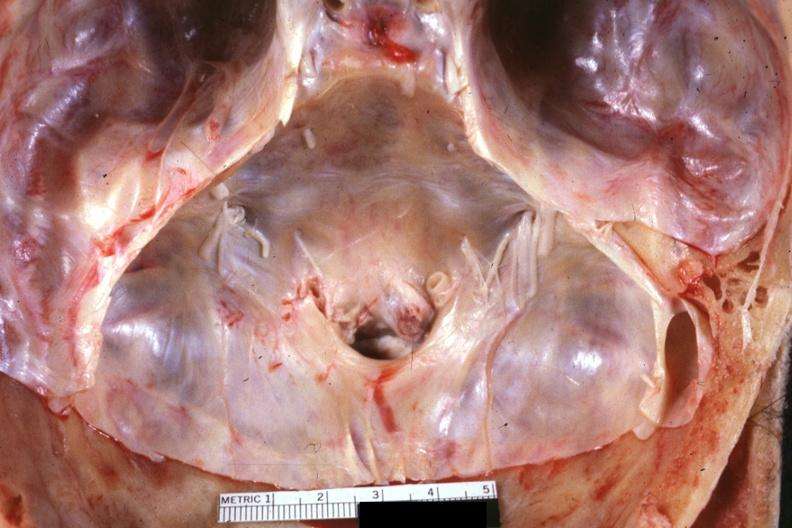what is present?
Answer the question using a single word or phrase. Rheumatoid arthritis 